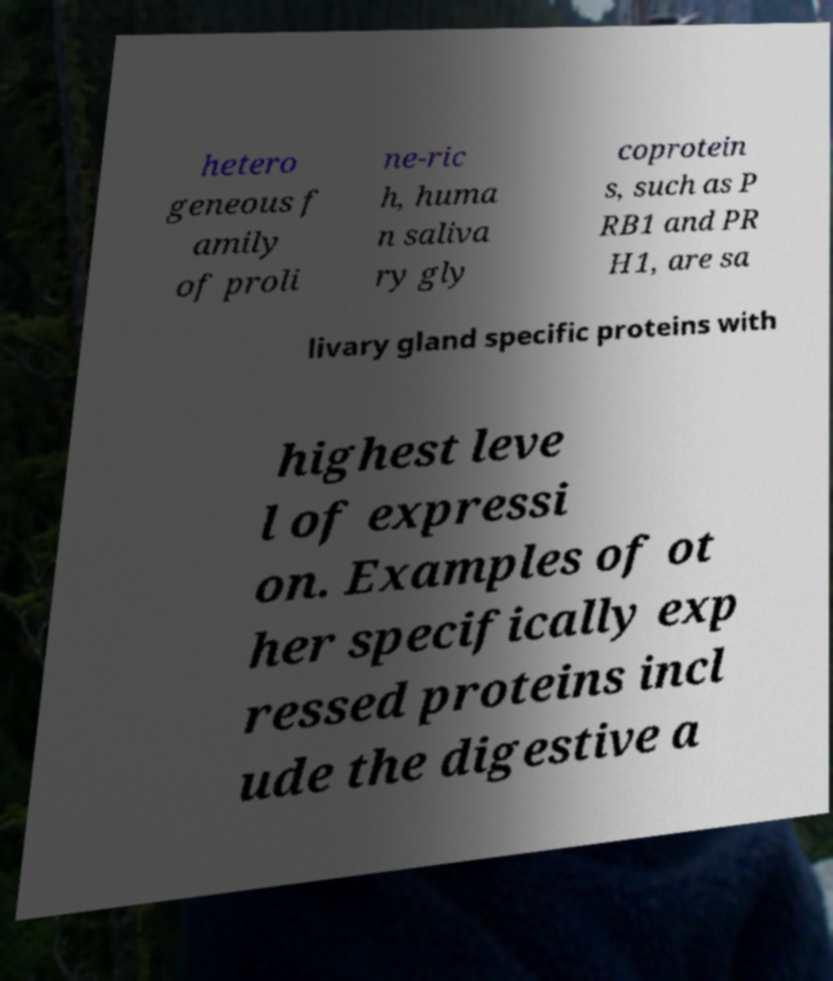Could you extract and type out the text from this image? hetero geneous f amily of proli ne-ric h, huma n saliva ry gly coprotein s, such as P RB1 and PR H1, are sa livary gland specific proteins with highest leve l of expressi on. Examples of ot her specifically exp ressed proteins incl ude the digestive a 